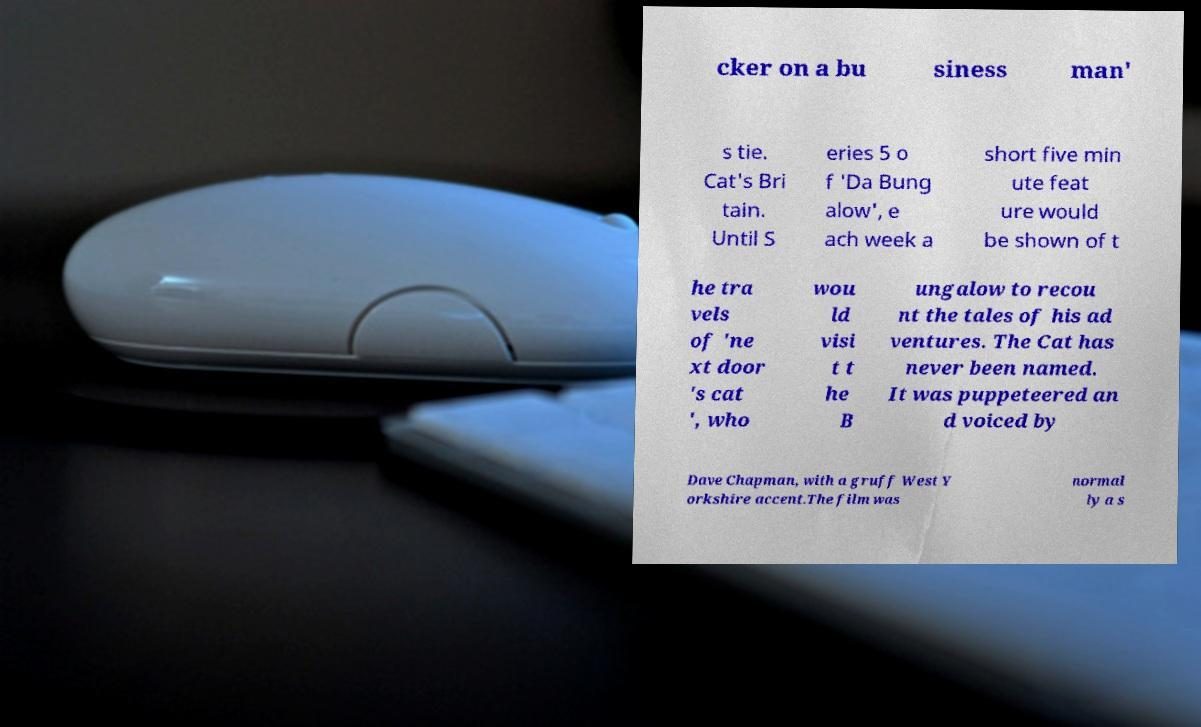Could you extract and type out the text from this image? cker on a bu siness man' s tie. Cat's Bri tain. Until S eries 5 o f 'Da Bung alow', e ach week a short five min ute feat ure would be shown of t he tra vels of 'ne xt door 's cat ', who wou ld visi t t he B ungalow to recou nt the tales of his ad ventures. The Cat has never been named. It was puppeteered an d voiced by Dave Chapman, with a gruff West Y orkshire accent.The film was normal ly a s 